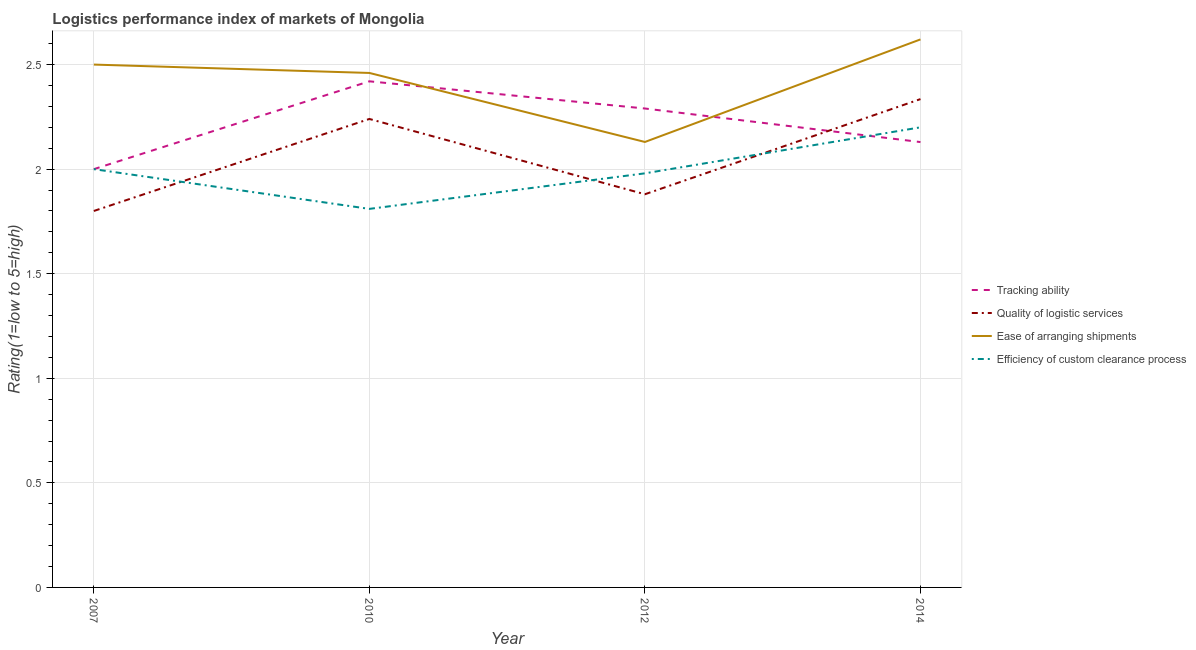How many different coloured lines are there?
Your response must be concise. 4. Is the number of lines equal to the number of legend labels?
Keep it short and to the point. Yes. What is the lpi rating of tracking ability in 2010?
Provide a succinct answer. 2.42. Across all years, what is the maximum lpi rating of tracking ability?
Provide a succinct answer. 2.42. Across all years, what is the minimum lpi rating of ease of arranging shipments?
Ensure brevity in your answer.  2.13. What is the total lpi rating of quality of logistic services in the graph?
Offer a very short reply. 8.25. What is the difference between the lpi rating of efficiency of custom clearance process in 2007 and that in 2012?
Provide a short and direct response. 0.02. What is the difference between the lpi rating of ease of arranging shipments in 2014 and the lpi rating of tracking ability in 2010?
Make the answer very short. 0.2. What is the average lpi rating of ease of arranging shipments per year?
Make the answer very short. 2.43. In the year 2012, what is the difference between the lpi rating of tracking ability and lpi rating of ease of arranging shipments?
Your answer should be very brief. 0.16. What is the ratio of the lpi rating of tracking ability in 2007 to that in 2010?
Keep it short and to the point. 0.83. Is the lpi rating of tracking ability in 2010 less than that in 2014?
Ensure brevity in your answer.  No. Is the difference between the lpi rating of efficiency of custom clearance process in 2007 and 2014 greater than the difference between the lpi rating of quality of logistic services in 2007 and 2014?
Provide a succinct answer. Yes. What is the difference between the highest and the second highest lpi rating of quality of logistic services?
Your answer should be very brief. 0.09. What is the difference between the highest and the lowest lpi rating of tracking ability?
Your response must be concise. 0.42. Does the lpi rating of tracking ability monotonically increase over the years?
Ensure brevity in your answer.  No. How many lines are there?
Make the answer very short. 4. How many years are there in the graph?
Offer a terse response. 4. What is the difference between two consecutive major ticks on the Y-axis?
Your response must be concise. 0.5. Are the values on the major ticks of Y-axis written in scientific E-notation?
Ensure brevity in your answer.  No. Does the graph contain any zero values?
Your answer should be compact. No. Does the graph contain grids?
Ensure brevity in your answer.  Yes. Where does the legend appear in the graph?
Ensure brevity in your answer.  Center right. How many legend labels are there?
Provide a short and direct response. 4. How are the legend labels stacked?
Your response must be concise. Vertical. What is the title of the graph?
Offer a very short reply. Logistics performance index of markets of Mongolia. What is the label or title of the X-axis?
Provide a short and direct response. Year. What is the label or title of the Y-axis?
Offer a very short reply. Rating(1=low to 5=high). What is the Rating(1=low to 5=high) of Ease of arranging shipments in 2007?
Give a very brief answer. 2.5. What is the Rating(1=low to 5=high) in Efficiency of custom clearance process in 2007?
Give a very brief answer. 2. What is the Rating(1=low to 5=high) of Tracking ability in 2010?
Provide a short and direct response. 2.42. What is the Rating(1=low to 5=high) in Quality of logistic services in 2010?
Your answer should be compact. 2.24. What is the Rating(1=low to 5=high) in Ease of arranging shipments in 2010?
Your answer should be compact. 2.46. What is the Rating(1=low to 5=high) in Efficiency of custom clearance process in 2010?
Keep it short and to the point. 1.81. What is the Rating(1=low to 5=high) in Tracking ability in 2012?
Keep it short and to the point. 2.29. What is the Rating(1=low to 5=high) of Quality of logistic services in 2012?
Your response must be concise. 1.88. What is the Rating(1=low to 5=high) in Ease of arranging shipments in 2012?
Your answer should be very brief. 2.13. What is the Rating(1=low to 5=high) in Efficiency of custom clearance process in 2012?
Provide a short and direct response. 1.98. What is the Rating(1=low to 5=high) of Tracking ability in 2014?
Your response must be concise. 2.13. What is the Rating(1=low to 5=high) in Quality of logistic services in 2014?
Keep it short and to the point. 2.33. What is the Rating(1=low to 5=high) of Ease of arranging shipments in 2014?
Give a very brief answer. 2.62. What is the Rating(1=low to 5=high) in Efficiency of custom clearance process in 2014?
Your answer should be very brief. 2.2. Across all years, what is the maximum Rating(1=low to 5=high) in Tracking ability?
Provide a short and direct response. 2.42. Across all years, what is the maximum Rating(1=low to 5=high) in Quality of logistic services?
Your answer should be compact. 2.33. Across all years, what is the maximum Rating(1=low to 5=high) in Ease of arranging shipments?
Your response must be concise. 2.62. Across all years, what is the maximum Rating(1=low to 5=high) in Efficiency of custom clearance process?
Ensure brevity in your answer.  2.2. Across all years, what is the minimum Rating(1=low to 5=high) of Tracking ability?
Ensure brevity in your answer.  2. Across all years, what is the minimum Rating(1=low to 5=high) of Quality of logistic services?
Give a very brief answer. 1.8. Across all years, what is the minimum Rating(1=low to 5=high) of Ease of arranging shipments?
Your response must be concise. 2.13. Across all years, what is the minimum Rating(1=low to 5=high) of Efficiency of custom clearance process?
Ensure brevity in your answer.  1.81. What is the total Rating(1=low to 5=high) in Tracking ability in the graph?
Make the answer very short. 8.84. What is the total Rating(1=low to 5=high) in Quality of logistic services in the graph?
Provide a short and direct response. 8.26. What is the total Rating(1=low to 5=high) of Ease of arranging shipments in the graph?
Your answer should be very brief. 9.71. What is the total Rating(1=low to 5=high) in Efficiency of custom clearance process in the graph?
Give a very brief answer. 7.99. What is the difference between the Rating(1=low to 5=high) in Tracking ability in 2007 and that in 2010?
Provide a short and direct response. -0.42. What is the difference between the Rating(1=low to 5=high) of Quality of logistic services in 2007 and that in 2010?
Provide a short and direct response. -0.44. What is the difference between the Rating(1=low to 5=high) in Efficiency of custom clearance process in 2007 and that in 2010?
Your answer should be compact. 0.19. What is the difference between the Rating(1=low to 5=high) of Tracking ability in 2007 and that in 2012?
Make the answer very short. -0.29. What is the difference between the Rating(1=low to 5=high) in Quality of logistic services in 2007 and that in 2012?
Your answer should be compact. -0.08. What is the difference between the Rating(1=low to 5=high) in Ease of arranging shipments in 2007 and that in 2012?
Make the answer very short. 0.37. What is the difference between the Rating(1=low to 5=high) in Tracking ability in 2007 and that in 2014?
Your answer should be very brief. -0.13. What is the difference between the Rating(1=low to 5=high) of Quality of logistic services in 2007 and that in 2014?
Offer a terse response. -0.54. What is the difference between the Rating(1=low to 5=high) in Ease of arranging shipments in 2007 and that in 2014?
Your answer should be very brief. -0.12. What is the difference between the Rating(1=low to 5=high) in Efficiency of custom clearance process in 2007 and that in 2014?
Provide a succinct answer. -0.2. What is the difference between the Rating(1=low to 5=high) of Tracking ability in 2010 and that in 2012?
Keep it short and to the point. 0.13. What is the difference between the Rating(1=low to 5=high) of Quality of logistic services in 2010 and that in 2012?
Offer a very short reply. 0.36. What is the difference between the Rating(1=low to 5=high) of Ease of arranging shipments in 2010 and that in 2012?
Your response must be concise. 0.33. What is the difference between the Rating(1=low to 5=high) of Efficiency of custom clearance process in 2010 and that in 2012?
Your answer should be compact. -0.17. What is the difference between the Rating(1=low to 5=high) of Tracking ability in 2010 and that in 2014?
Your response must be concise. 0.29. What is the difference between the Rating(1=low to 5=high) of Quality of logistic services in 2010 and that in 2014?
Provide a succinct answer. -0.1. What is the difference between the Rating(1=low to 5=high) in Ease of arranging shipments in 2010 and that in 2014?
Ensure brevity in your answer.  -0.16. What is the difference between the Rating(1=low to 5=high) in Efficiency of custom clearance process in 2010 and that in 2014?
Your response must be concise. -0.39. What is the difference between the Rating(1=low to 5=high) of Tracking ability in 2012 and that in 2014?
Ensure brevity in your answer.  0.16. What is the difference between the Rating(1=low to 5=high) in Quality of logistic services in 2012 and that in 2014?
Offer a terse response. -0.46. What is the difference between the Rating(1=low to 5=high) in Ease of arranging shipments in 2012 and that in 2014?
Provide a succinct answer. -0.49. What is the difference between the Rating(1=low to 5=high) of Efficiency of custom clearance process in 2012 and that in 2014?
Your answer should be very brief. -0.22. What is the difference between the Rating(1=low to 5=high) of Tracking ability in 2007 and the Rating(1=low to 5=high) of Quality of logistic services in 2010?
Your response must be concise. -0.24. What is the difference between the Rating(1=low to 5=high) of Tracking ability in 2007 and the Rating(1=low to 5=high) of Ease of arranging shipments in 2010?
Ensure brevity in your answer.  -0.46. What is the difference between the Rating(1=low to 5=high) in Tracking ability in 2007 and the Rating(1=low to 5=high) in Efficiency of custom clearance process in 2010?
Offer a terse response. 0.19. What is the difference between the Rating(1=low to 5=high) of Quality of logistic services in 2007 and the Rating(1=low to 5=high) of Ease of arranging shipments in 2010?
Your answer should be very brief. -0.66. What is the difference between the Rating(1=low to 5=high) in Quality of logistic services in 2007 and the Rating(1=low to 5=high) in Efficiency of custom clearance process in 2010?
Keep it short and to the point. -0.01. What is the difference between the Rating(1=low to 5=high) in Ease of arranging shipments in 2007 and the Rating(1=low to 5=high) in Efficiency of custom clearance process in 2010?
Your response must be concise. 0.69. What is the difference between the Rating(1=low to 5=high) of Tracking ability in 2007 and the Rating(1=low to 5=high) of Quality of logistic services in 2012?
Your answer should be very brief. 0.12. What is the difference between the Rating(1=low to 5=high) of Tracking ability in 2007 and the Rating(1=low to 5=high) of Ease of arranging shipments in 2012?
Make the answer very short. -0.13. What is the difference between the Rating(1=low to 5=high) of Tracking ability in 2007 and the Rating(1=low to 5=high) of Efficiency of custom clearance process in 2012?
Offer a terse response. 0.02. What is the difference between the Rating(1=low to 5=high) of Quality of logistic services in 2007 and the Rating(1=low to 5=high) of Ease of arranging shipments in 2012?
Make the answer very short. -0.33. What is the difference between the Rating(1=low to 5=high) in Quality of logistic services in 2007 and the Rating(1=low to 5=high) in Efficiency of custom clearance process in 2012?
Your answer should be compact. -0.18. What is the difference between the Rating(1=low to 5=high) of Ease of arranging shipments in 2007 and the Rating(1=low to 5=high) of Efficiency of custom clearance process in 2012?
Offer a very short reply. 0.52. What is the difference between the Rating(1=low to 5=high) of Tracking ability in 2007 and the Rating(1=low to 5=high) of Quality of logistic services in 2014?
Give a very brief answer. -0.34. What is the difference between the Rating(1=low to 5=high) in Tracking ability in 2007 and the Rating(1=low to 5=high) in Ease of arranging shipments in 2014?
Keep it short and to the point. -0.62. What is the difference between the Rating(1=low to 5=high) in Quality of logistic services in 2007 and the Rating(1=low to 5=high) in Ease of arranging shipments in 2014?
Make the answer very short. -0.82. What is the difference between the Rating(1=low to 5=high) in Ease of arranging shipments in 2007 and the Rating(1=low to 5=high) in Efficiency of custom clearance process in 2014?
Give a very brief answer. 0.3. What is the difference between the Rating(1=low to 5=high) of Tracking ability in 2010 and the Rating(1=low to 5=high) of Quality of logistic services in 2012?
Make the answer very short. 0.54. What is the difference between the Rating(1=low to 5=high) in Tracking ability in 2010 and the Rating(1=low to 5=high) in Ease of arranging shipments in 2012?
Offer a terse response. 0.29. What is the difference between the Rating(1=low to 5=high) of Tracking ability in 2010 and the Rating(1=low to 5=high) of Efficiency of custom clearance process in 2012?
Make the answer very short. 0.44. What is the difference between the Rating(1=low to 5=high) of Quality of logistic services in 2010 and the Rating(1=low to 5=high) of Ease of arranging shipments in 2012?
Keep it short and to the point. 0.11. What is the difference between the Rating(1=low to 5=high) of Quality of logistic services in 2010 and the Rating(1=low to 5=high) of Efficiency of custom clearance process in 2012?
Your response must be concise. 0.26. What is the difference between the Rating(1=low to 5=high) in Ease of arranging shipments in 2010 and the Rating(1=low to 5=high) in Efficiency of custom clearance process in 2012?
Keep it short and to the point. 0.48. What is the difference between the Rating(1=low to 5=high) in Tracking ability in 2010 and the Rating(1=low to 5=high) in Quality of logistic services in 2014?
Your response must be concise. 0.09. What is the difference between the Rating(1=low to 5=high) in Tracking ability in 2010 and the Rating(1=low to 5=high) in Ease of arranging shipments in 2014?
Ensure brevity in your answer.  -0.2. What is the difference between the Rating(1=low to 5=high) of Tracking ability in 2010 and the Rating(1=low to 5=high) of Efficiency of custom clearance process in 2014?
Your answer should be compact. 0.22. What is the difference between the Rating(1=low to 5=high) of Quality of logistic services in 2010 and the Rating(1=low to 5=high) of Ease of arranging shipments in 2014?
Offer a terse response. -0.38. What is the difference between the Rating(1=low to 5=high) in Quality of logistic services in 2010 and the Rating(1=low to 5=high) in Efficiency of custom clearance process in 2014?
Make the answer very short. 0.04. What is the difference between the Rating(1=low to 5=high) of Ease of arranging shipments in 2010 and the Rating(1=low to 5=high) of Efficiency of custom clearance process in 2014?
Provide a short and direct response. 0.26. What is the difference between the Rating(1=low to 5=high) in Tracking ability in 2012 and the Rating(1=low to 5=high) in Quality of logistic services in 2014?
Ensure brevity in your answer.  -0.04. What is the difference between the Rating(1=low to 5=high) in Tracking ability in 2012 and the Rating(1=low to 5=high) in Ease of arranging shipments in 2014?
Give a very brief answer. -0.33. What is the difference between the Rating(1=low to 5=high) in Tracking ability in 2012 and the Rating(1=low to 5=high) in Efficiency of custom clearance process in 2014?
Ensure brevity in your answer.  0.09. What is the difference between the Rating(1=low to 5=high) of Quality of logistic services in 2012 and the Rating(1=low to 5=high) of Ease of arranging shipments in 2014?
Offer a terse response. -0.74. What is the difference between the Rating(1=low to 5=high) in Quality of logistic services in 2012 and the Rating(1=low to 5=high) in Efficiency of custom clearance process in 2014?
Make the answer very short. -0.32. What is the difference between the Rating(1=low to 5=high) of Ease of arranging shipments in 2012 and the Rating(1=low to 5=high) of Efficiency of custom clearance process in 2014?
Your response must be concise. -0.07. What is the average Rating(1=low to 5=high) in Tracking ability per year?
Give a very brief answer. 2.21. What is the average Rating(1=low to 5=high) in Quality of logistic services per year?
Your response must be concise. 2.06. What is the average Rating(1=low to 5=high) in Ease of arranging shipments per year?
Your answer should be very brief. 2.43. What is the average Rating(1=low to 5=high) in Efficiency of custom clearance process per year?
Your answer should be very brief. 2. In the year 2007, what is the difference between the Rating(1=low to 5=high) of Tracking ability and Rating(1=low to 5=high) of Quality of logistic services?
Offer a terse response. 0.2. In the year 2007, what is the difference between the Rating(1=low to 5=high) in Tracking ability and Rating(1=low to 5=high) in Ease of arranging shipments?
Keep it short and to the point. -0.5. In the year 2007, what is the difference between the Rating(1=low to 5=high) of Tracking ability and Rating(1=low to 5=high) of Efficiency of custom clearance process?
Your response must be concise. 0. In the year 2007, what is the difference between the Rating(1=low to 5=high) of Quality of logistic services and Rating(1=low to 5=high) of Ease of arranging shipments?
Give a very brief answer. -0.7. In the year 2010, what is the difference between the Rating(1=low to 5=high) of Tracking ability and Rating(1=low to 5=high) of Quality of logistic services?
Your answer should be very brief. 0.18. In the year 2010, what is the difference between the Rating(1=low to 5=high) of Tracking ability and Rating(1=low to 5=high) of Ease of arranging shipments?
Provide a succinct answer. -0.04. In the year 2010, what is the difference between the Rating(1=low to 5=high) in Tracking ability and Rating(1=low to 5=high) in Efficiency of custom clearance process?
Offer a terse response. 0.61. In the year 2010, what is the difference between the Rating(1=low to 5=high) in Quality of logistic services and Rating(1=low to 5=high) in Ease of arranging shipments?
Your answer should be compact. -0.22. In the year 2010, what is the difference between the Rating(1=low to 5=high) of Quality of logistic services and Rating(1=low to 5=high) of Efficiency of custom clearance process?
Make the answer very short. 0.43. In the year 2010, what is the difference between the Rating(1=low to 5=high) in Ease of arranging shipments and Rating(1=low to 5=high) in Efficiency of custom clearance process?
Ensure brevity in your answer.  0.65. In the year 2012, what is the difference between the Rating(1=low to 5=high) of Tracking ability and Rating(1=low to 5=high) of Quality of logistic services?
Your response must be concise. 0.41. In the year 2012, what is the difference between the Rating(1=low to 5=high) of Tracking ability and Rating(1=low to 5=high) of Ease of arranging shipments?
Your response must be concise. 0.16. In the year 2012, what is the difference between the Rating(1=low to 5=high) of Tracking ability and Rating(1=low to 5=high) of Efficiency of custom clearance process?
Your answer should be very brief. 0.31. In the year 2012, what is the difference between the Rating(1=low to 5=high) in Quality of logistic services and Rating(1=low to 5=high) in Ease of arranging shipments?
Ensure brevity in your answer.  -0.25. In the year 2012, what is the difference between the Rating(1=low to 5=high) in Quality of logistic services and Rating(1=low to 5=high) in Efficiency of custom clearance process?
Offer a very short reply. -0.1. In the year 2012, what is the difference between the Rating(1=low to 5=high) in Ease of arranging shipments and Rating(1=low to 5=high) in Efficiency of custom clearance process?
Your answer should be very brief. 0.15. In the year 2014, what is the difference between the Rating(1=low to 5=high) in Tracking ability and Rating(1=low to 5=high) in Quality of logistic services?
Your answer should be very brief. -0.21. In the year 2014, what is the difference between the Rating(1=low to 5=high) of Tracking ability and Rating(1=low to 5=high) of Ease of arranging shipments?
Offer a very short reply. -0.49. In the year 2014, what is the difference between the Rating(1=low to 5=high) in Tracking ability and Rating(1=low to 5=high) in Efficiency of custom clearance process?
Keep it short and to the point. -0.07. In the year 2014, what is the difference between the Rating(1=low to 5=high) of Quality of logistic services and Rating(1=low to 5=high) of Ease of arranging shipments?
Offer a very short reply. -0.29. In the year 2014, what is the difference between the Rating(1=low to 5=high) of Quality of logistic services and Rating(1=low to 5=high) of Efficiency of custom clearance process?
Keep it short and to the point. 0.14. In the year 2014, what is the difference between the Rating(1=low to 5=high) of Ease of arranging shipments and Rating(1=low to 5=high) of Efficiency of custom clearance process?
Offer a terse response. 0.42. What is the ratio of the Rating(1=low to 5=high) of Tracking ability in 2007 to that in 2010?
Your answer should be compact. 0.83. What is the ratio of the Rating(1=low to 5=high) in Quality of logistic services in 2007 to that in 2010?
Offer a terse response. 0.8. What is the ratio of the Rating(1=low to 5=high) in Ease of arranging shipments in 2007 to that in 2010?
Make the answer very short. 1.02. What is the ratio of the Rating(1=low to 5=high) in Efficiency of custom clearance process in 2007 to that in 2010?
Your response must be concise. 1.1. What is the ratio of the Rating(1=low to 5=high) in Tracking ability in 2007 to that in 2012?
Provide a succinct answer. 0.87. What is the ratio of the Rating(1=low to 5=high) in Quality of logistic services in 2007 to that in 2012?
Provide a short and direct response. 0.96. What is the ratio of the Rating(1=low to 5=high) in Ease of arranging shipments in 2007 to that in 2012?
Keep it short and to the point. 1.17. What is the ratio of the Rating(1=low to 5=high) in Efficiency of custom clearance process in 2007 to that in 2012?
Offer a very short reply. 1.01. What is the ratio of the Rating(1=low to 5=high) of Tracking ability in 2007 to that in 2014?
Ensure brevity in your answer.  0.94. What is the ratio of the Rating(1=low to 5=high) in Quality of logistic services in 2007 to that in 2014?
Your answer should be very brief. 0.77. What is the ratio of the Rating(1=low to 5=high) in Ease of arranging shipments in 2007 to that in 2014?
Offer a terse response. 0.95. What is the ratio of the Rating(1=low to 5=high) of Efficiency of custom clearance process in 2007 to that in 2014?
Make the answer very short. 0.91. What is the ratio of the Rating(1=low to 5=high) of Tracking ability in 2010 to that in 2012?
Provide a short and direct response. 1.06. What is the ratio of the Rating(1=low to 5=high) of Quality of logistic services in 2010 to that in 2012?
Provide a short and direct response. 1.19. What is the ratio of the Rating(1=low to 5=high) of Ease of arranging shipments in 2010 to that in 2012?
Make the answer very short. 1.15. What is the ratio of the Rating(1=low to 5=high) of Efficiency of custom clearance process in 2010 to that in 2012?
Provide a short and direct response. 0.91. What is the ratio of the Rating(1=low to 5=high) in Tracking ability in 2010 to that in 2014?
Your response must be concise. 1.14. What is the ratio of the Rating(1=low to 5=high) of Quality of logistic services in 2010 to that in 2014?
Make the answer very short. 0.96. What is the ratio of the Rating(1=low to 5=high) in Ease of arranging shipments in 2010 to that in 2014?
Your answer should be compact. 0.94. What is the ratio of the Rating(1=low to 5=high) of Efficiency of custom clearance process in 2010 to that in 2014?
Provide a succinct answer. 0.82. What is the ratio of the Rating(1=low to 5=high) in Tracking ability in 2012 to that in 2014?
Provide a succinct answer. 1.08. What is the ratio of the Rating(1=low to 5=high) of Quality of logistic services in 2012 to that in 2014?
Offer a very short reply. 0.81. What is the ratio of the Rating(1=low to 5=high) in Ease of arranging shipments in 2012 to that in 2014?
Offer a very short reply. 0.81. What is the difference between the highest and the second highest Rating(1=low to 5=high) of Tracking ability?
Keep it short and to the point. 0.13. What is the difference between the highest and the second highest Rating(1=low to 5=high) of Quality of logistic services?
Your response must be concise. 0.1. What is the difference between the highest and the second highest Rating(1=low to 5=high) of Ease of arranging shipments?
Make the answer very short. 0.12. What is the difference between the highest and the lowest Rating(1=low to 5=high) of Tracking ability?
Provide a succinct answer. 0.42. What is the difference between the highest and the lowest Rating(1=low to 5=high) of Quality of logistic services?
Offer a very short reply. 0.54. What is the difference between the highest and the lowest Rating(1=low to 5=high) in Ease of arranging shipments?
Provide a short and direct response. 0.49. What is the difference between the highest and the lowest Rating(1=low to 5=high) in Efficiency of custom clearance process?
Offer a very short reply. 0.39. 